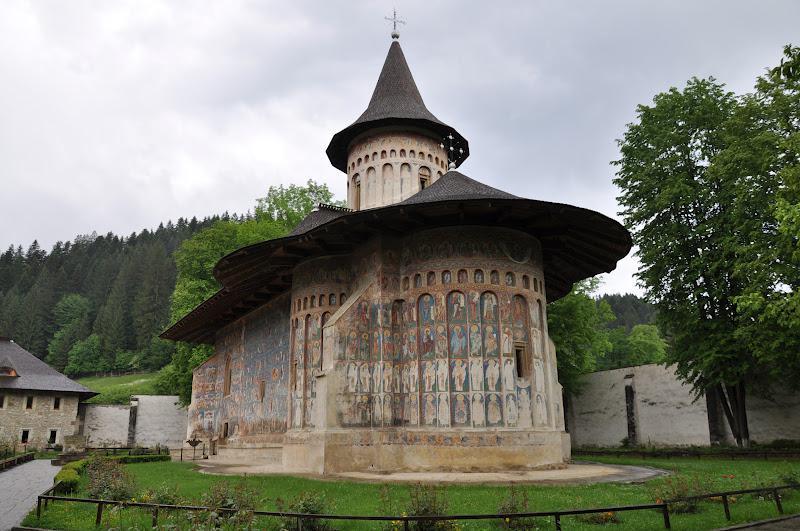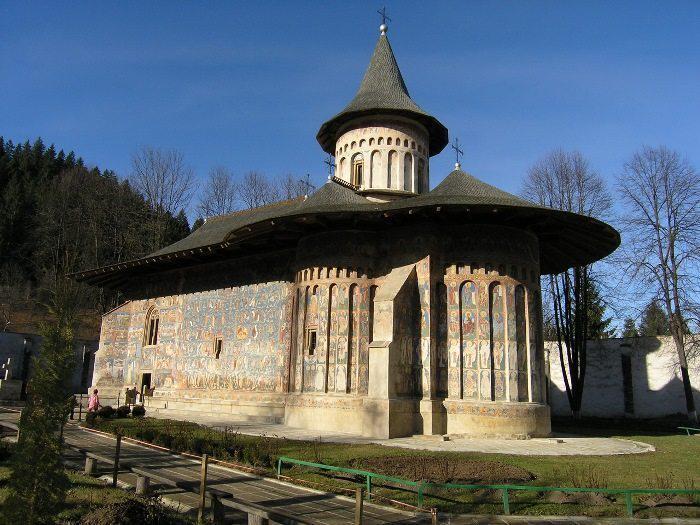The first image is the image on the left, the second image is the image on the right. Given the left and right images, does the statement "The left and right image contains the same number of inside churches facing north and right." hold true? Answer yes or no. Yes. The first image is the image on the left, the second image is the image on the right. Examine the images to the left and right. Is the description "You can see a lawn surrounding the church in both images." accurate? Answer yes or no. Yes. 